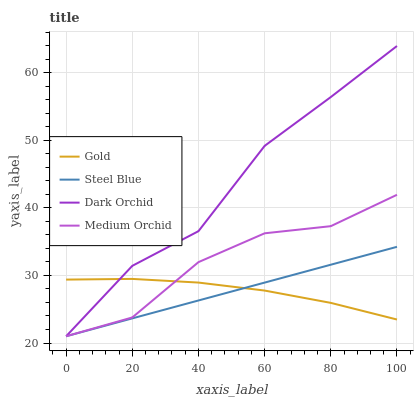Does Steel Blue have the minimum area under the curve?
Answer yes or no. Yes. Does Dark Orchid have the maximum area under the curve?
Answer yes or no. Yes. Does Medium Orchid have the minimum area under the curve?
Answer yes or no. No. Does Medium Orchid have the maximum area under the curve?
Answer yes or no. No. Is Steel Blue the smoothest?
Answer yes or no. Yes. Is Dark Orchid the roughest?
Answer yes or no. Yes. Is Medium Orchid the smoothest?
Answer yes or no. No. Is Medium Orchid the roughest?
Answer yes or no. No. Does Dark Orchid have the lowest value?
Answer yes or no. Yes. Does Gold have the lowest value?
Answer yes or no. No. Does Dark Orchid have the highest value?
Answer yes or no. Yes. Does Medium Orchid have the highest value?
Answer yes or no. No. Does Gold intersect Dark Orchid?
Answer yes or no. Yes. Is Gold less than Dark Orchid?
Answer yes or no. No. Is Gold greater than Dark Orchid?
Answer yes or no. No. 